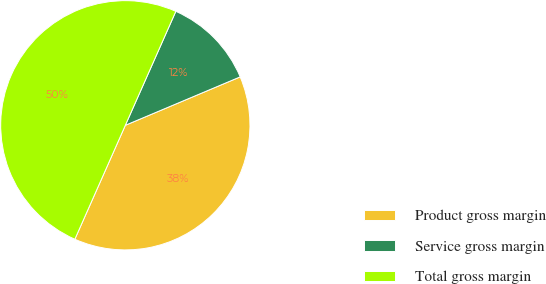Convert chart. <chart><loc_0><loc_0><loc_500><loc_500><pie_chart><fcel>Product gross margin<fcel>Service gross margin<fcel>Total gross margin<nl><fcel>37.99%<fcel>12.01%<fcel>50.0%<nl></chart> 